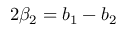Convert formula to latex. <formula><loc_0><loc_0><loc_500><loc_500>2 \beta _ { 2 } = b _ { 1 } - b _ { 2 }</formula> 